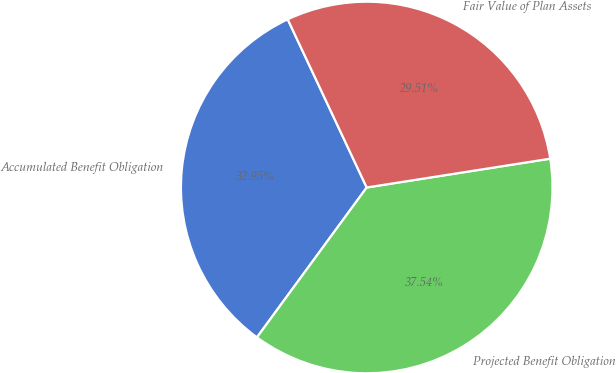Convert chart. <chart><loc_0><loc_0><loc_500><loc_500><pie_chart><fcel>Accumulated Benefit Obligation<fcel>Projected Benefit Obligation<fcel>Fair Value of Plan Assets<nl><fcel>32.95%<fcel>37.54%<fcel>29.51%<nl></chart> 